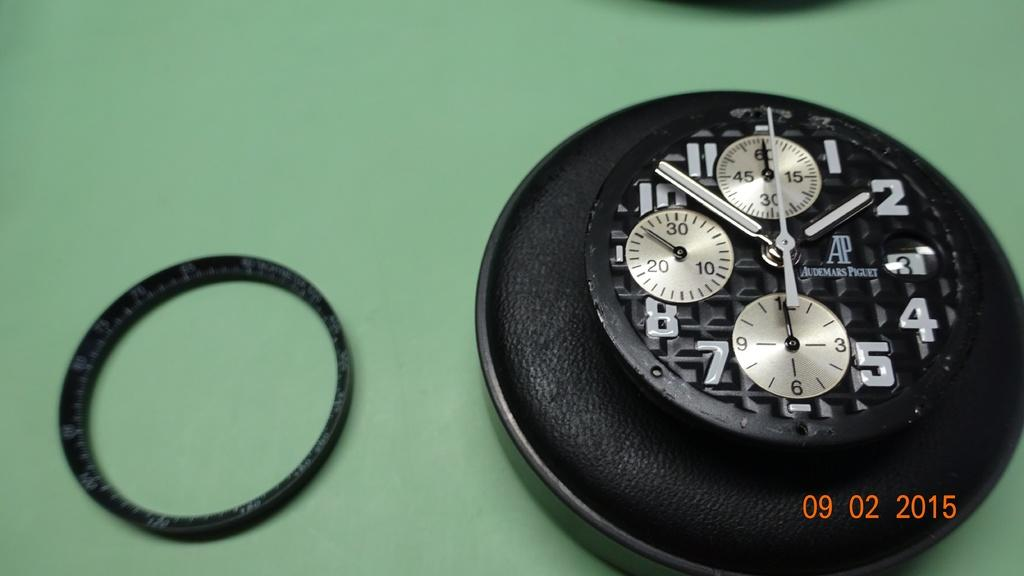<image>
Render a clear and concise summary of the photo. Face of a watch with the word Audemars Piguet on it as well. 